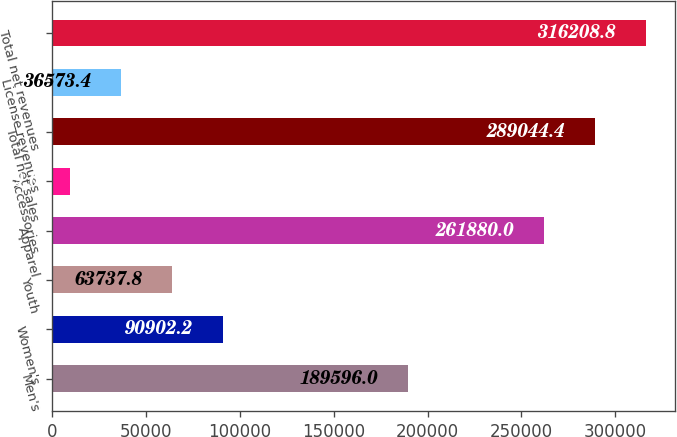<chart> <loc_0><loc_0><loc_500><loc_500><bar_chart><fcel>Men's<fcel>Women's<fcel>Youth<fcel>Apparel<fcel>Accessories<fcel>Total net sales<fcel>License revenues<fcel>Total net revenues<nl><fcel>189596<fcel>90902.2<fcel>63737.8<fcel>261880<fcel>9409<fcel>289044<fcel>36573.4<fcel>316209<nl></chart> 